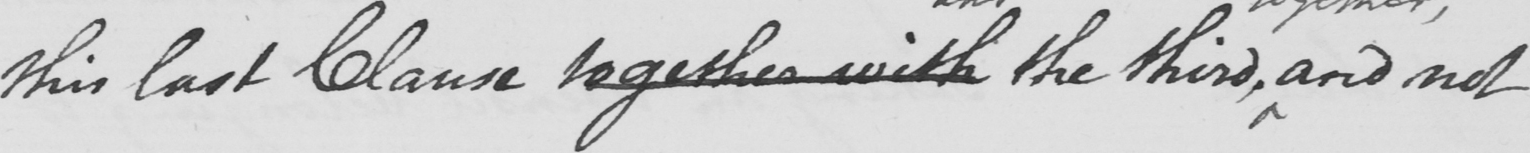Transcribe the text shown in this historical manuscript line. this last Clause together with the third , and not 